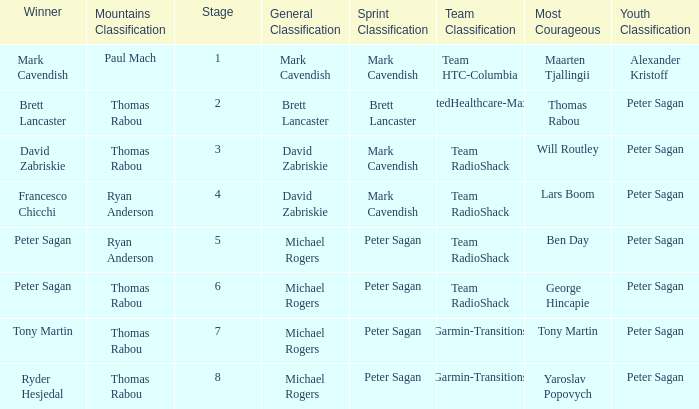Who won the mountains classification when Maarten Tjallingii won most corageous? Paul Mach. Could you help me parse every detail presented in this table? {'header': ['Winner', 'Mountains Classification', 'Stage', 'General Classification', 'Sprint Classification', 'Team Classification', 'Most Courageous', 'Youth Classification'], 'rows': [['Mark Cavendish', 'Paul Mach', '1', 'Mark Cavendish', 'Mark Cavendish', 'Team HTC-Columbia', 'Maarten Tjallingii', 'Alexander Kristoff'], ['Brett Lancaster', 'Thomas Rabou', '2', 'Brett Lancaster', 'Brett Lancaster', 'UnitedHealthcare-Maxxis', 'Thomas Rabou', 'Peter Sagan'], ['David Zabriskie', 'Thomas Rabou', '3', 'David Zabriskie', 'Mark Cavendish', 'Team RadioShack', 'Will Routley', 'Peter Sagan'], ['Francesco Chicchi', 'Ryan Anderson', '4', 'David Zabriskie', 'Mark Cavendish', 'Team RadioShack', 'Lars Boom', 'Peter Sagan'], ['Peter Sagan', 'Ryan Anderson', '5', 'Michael Rogers', 'Peter Sagan', 'Team RadioShack', 'Ben Day', 'Peter Sagan'], ['Peter Sagan', 'Thomas Rabou', '6', 'Michael Rogers', 'Peter Sagan', 'Team RadioShack', 'George Hincapie', 'Peter Sagan'], ['Tony Martin', 'Thomas Rabou', '7', 'Michael Rogers', 'Peter Sagan', 'Garmin-Transitions', 'Tony Martin', 'Peter Sagan'], ['Ryder Hesjedal', 'Thomas Rabou', '8', 'Michael Rogers', 'Peter Sagan', 'Garmin-Transitions', 'Yaroslav Popovych', 'Peter Sagan']]} 